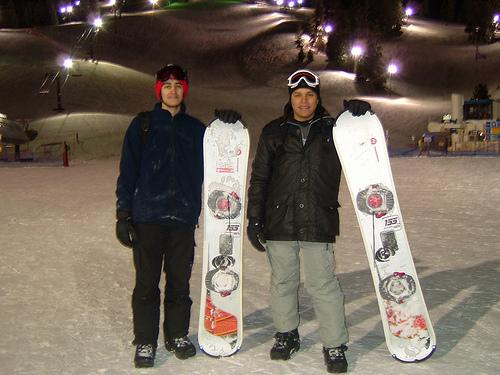Why are the lights on at this ski resort? Please explain your reasoning. it's night. The lights are one because it is night. 